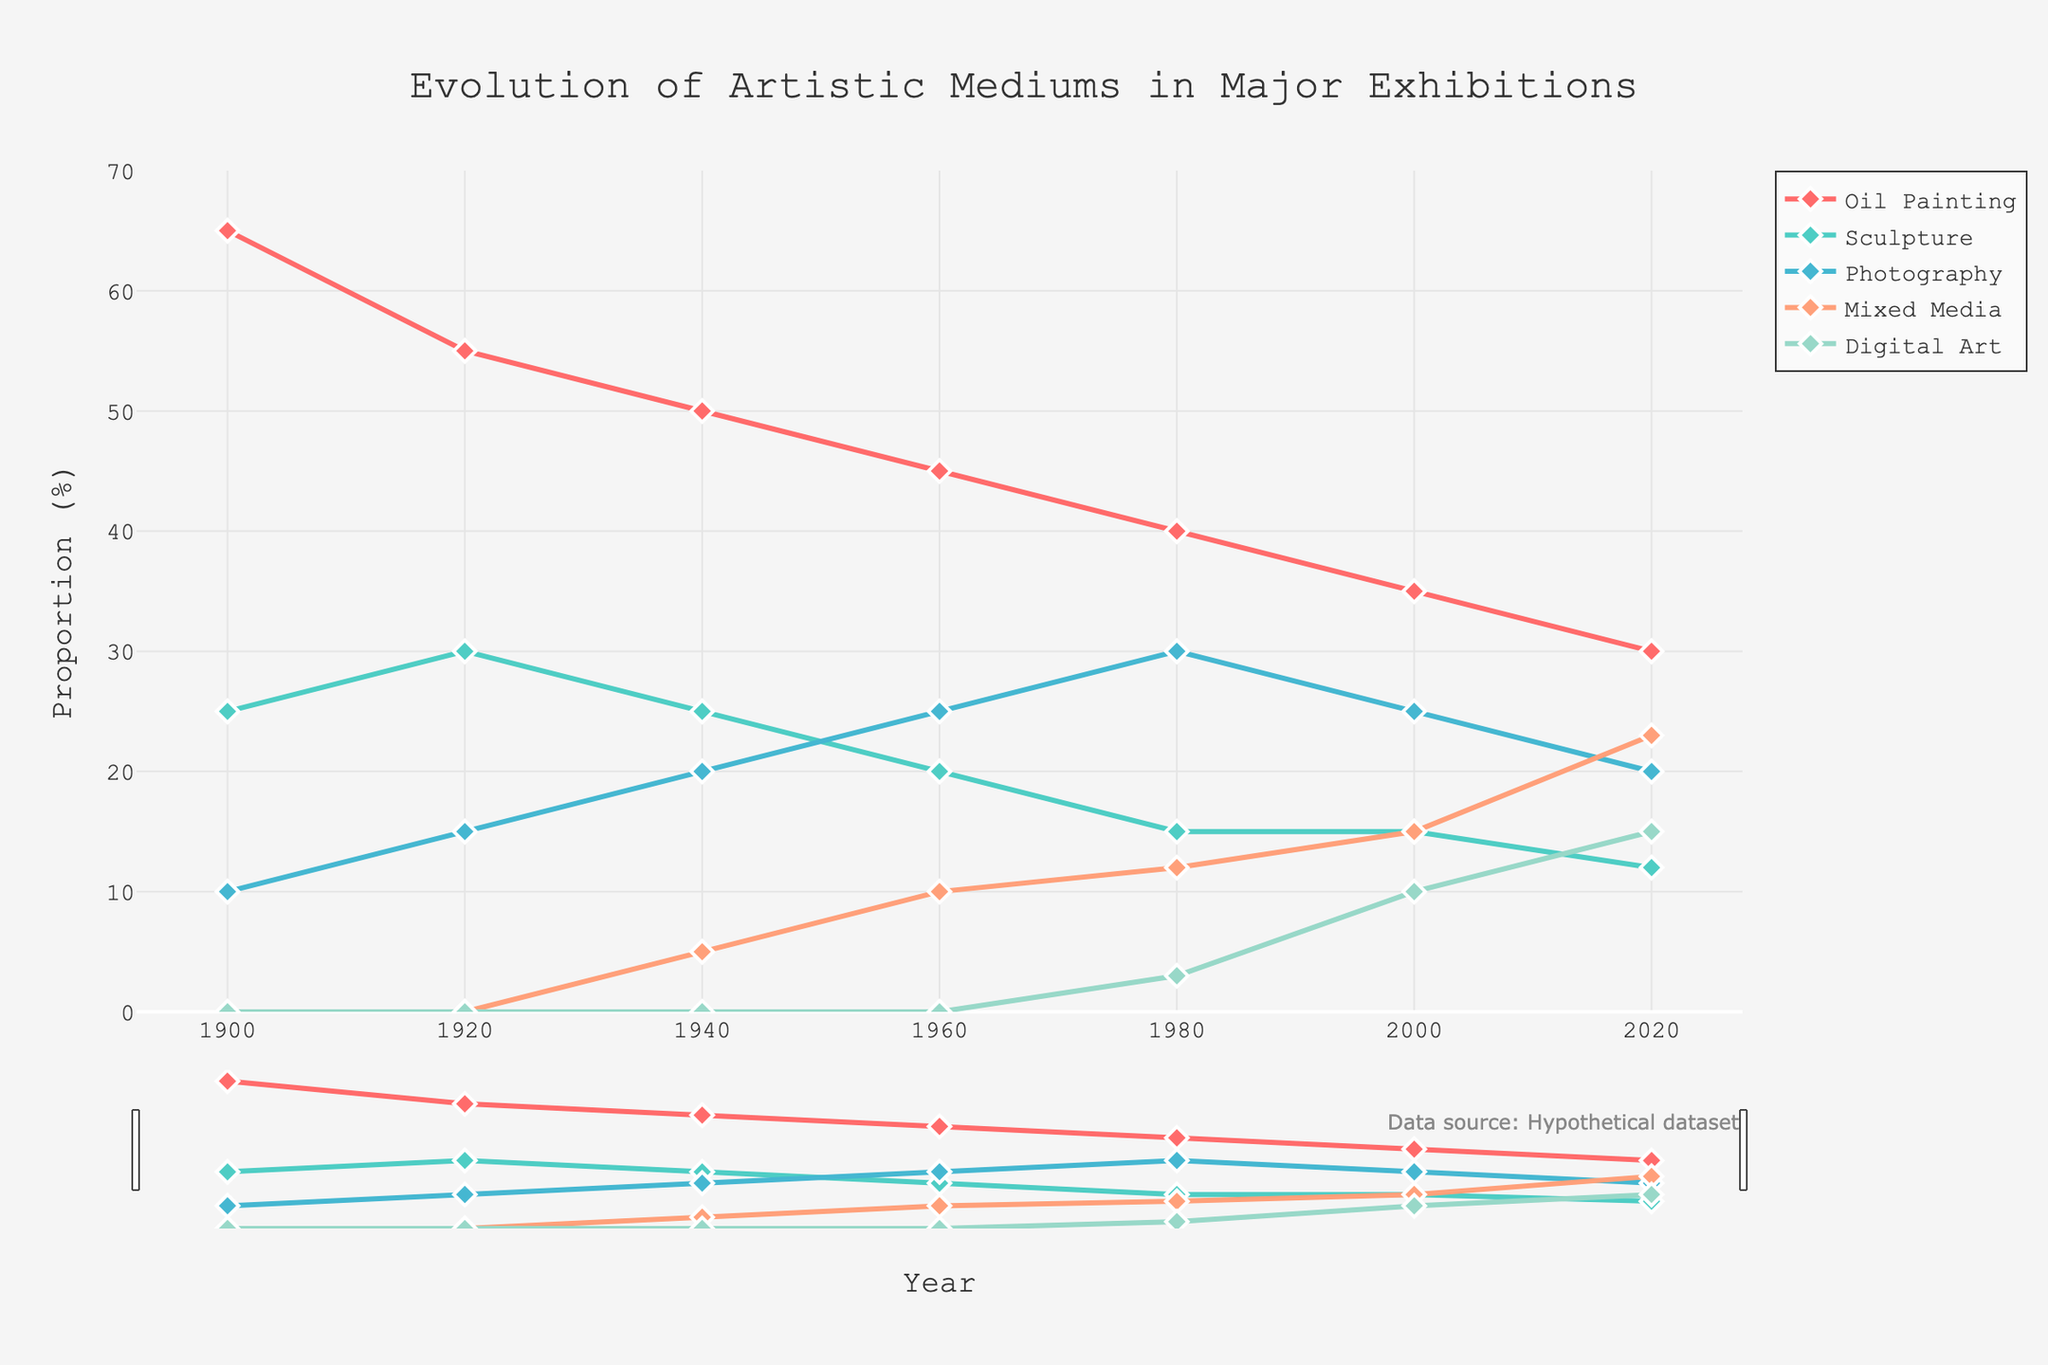what is the proportion of Oil Painting in 1900 and 2020, respectively? The line chart shows the proportion of Oil Painting in 1900 at 65% and in 2020 at 30%. Just locate the points for Oil Painting at these years.
Answer: 65% and 30% Which medium had the most significant increase from 1900 to 2020? By examining the lines from 1900 to 2020, Photography shows a rise from 10% to 20%, but Digital Art increases from 0% to 15%, which is the highest rise.
Answer: Digital Art Which artistic medium showed a constant proportion from 1940 to 2000? Review the lines between 1940 and 2000; Sculpture remains constant at 15% during this period. This can be seen by the flat line segment for Sculpture.
Answer: Sculpture In what year did Mixed Media exceed Photography in proportion for the first time? Comparing the lines of Mixed Media and Photography, Mixed Media surpasses Photography in 2020, where Mixed Media is 23% and Photography is 20%.
Answer: 2020 Between 1960 and 1980, which medium's proportion dropped by 5 percentage points? By comparing proportions in 1960 and 1980, the lines show Oil Painting dropped from 45% to 40%, a 5 percentage points decrease.
Answer: Oil Painting What is the proportion sum of Sculpture and Digital Art in 2000? In the year 2000, the proportion for Sculpture is 15%, and for Digital Art is 10%. Adding these gives 15% + 10% = 25%.
Answer: 25% Did any medium maintain a perfect linear trend from 1900 to 2020? Observing all lines for linearity: Digital Art, starting in 1980, and Mixed Media since introduced, show relatively linear trends but are not perfect over the entire period from 1900 to 2020. Therefore, none are perfect.
Answer: None How does the proportion of Mixed Media in 2020 compare to Oil Painting in 1920? The chart indicates Mixed Media in 2020 is 23%. Oil Painting in 1920 is 55%. Comparing both, Mixed Media is less.
Answer: Less Which medium has the lowest proportion in 1920? By examining the chart at 1920, the proportion for Photography is 15%, which is the lowest among the listed mediums.
Answer: Photography 